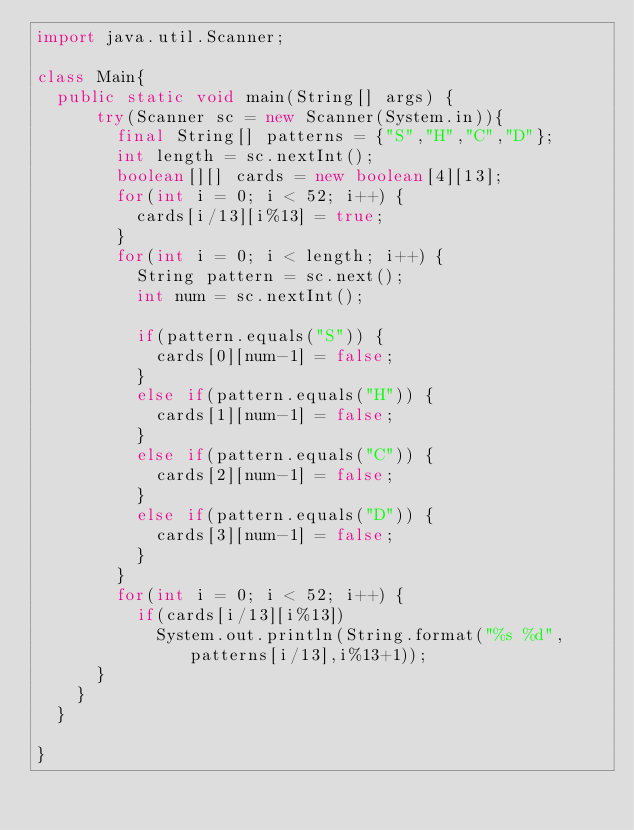<code> <loc_0><loc_0><loc_500><loc_500><_Java_>import java.util.Scanner;

class Main{
	public static void main(String[] args) {
			try(Scanner sc = new Scanner(System.in)){
				final String[] patterns = {"S","H","C","D"};
				int length = sc.nextInt();
				boolean[][] cards = new boolean[4][13];
				for(int i = 0; i < 52; i++) {
					cards[i/13][i%13] = true;
				}
				for(int i = 0; i < length; i++) {
					String pattern = sc.next();
					int num = sc.nextInt();

					if(pattern.equals("S")) {
						cards[0][num-1] = false;
					}
					else if(pattern.equals("H")) {
						cards[1][num-1] = false;
					}
					else if(pattern.equals("C")) {
						cards[2][num-1] = false;
					}
					else if(pattern.equals("D")) {
						cards[3][num-1] = false;
					}
				}
				for(int i = 0; i < 52; i++) {
					if(cards[i/13][i%13])
						System.out.println(String.format("%s %d", patterns[i/13],i%13+1));
			}
		}
	}

}

</code> 